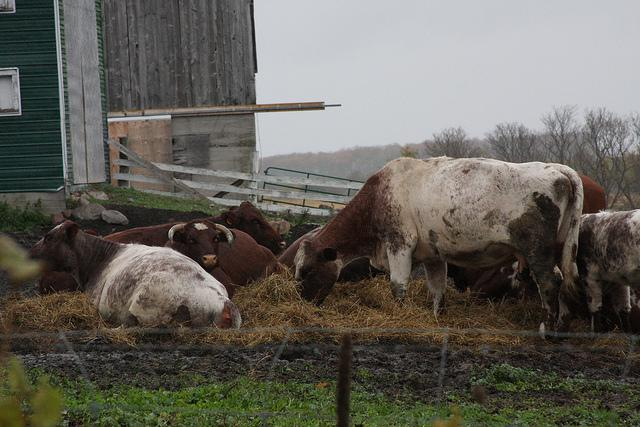The cows main food source for nutrition is brought out in what shape? Please explain your reasoning. barrels. The hay is brought in barrels. 